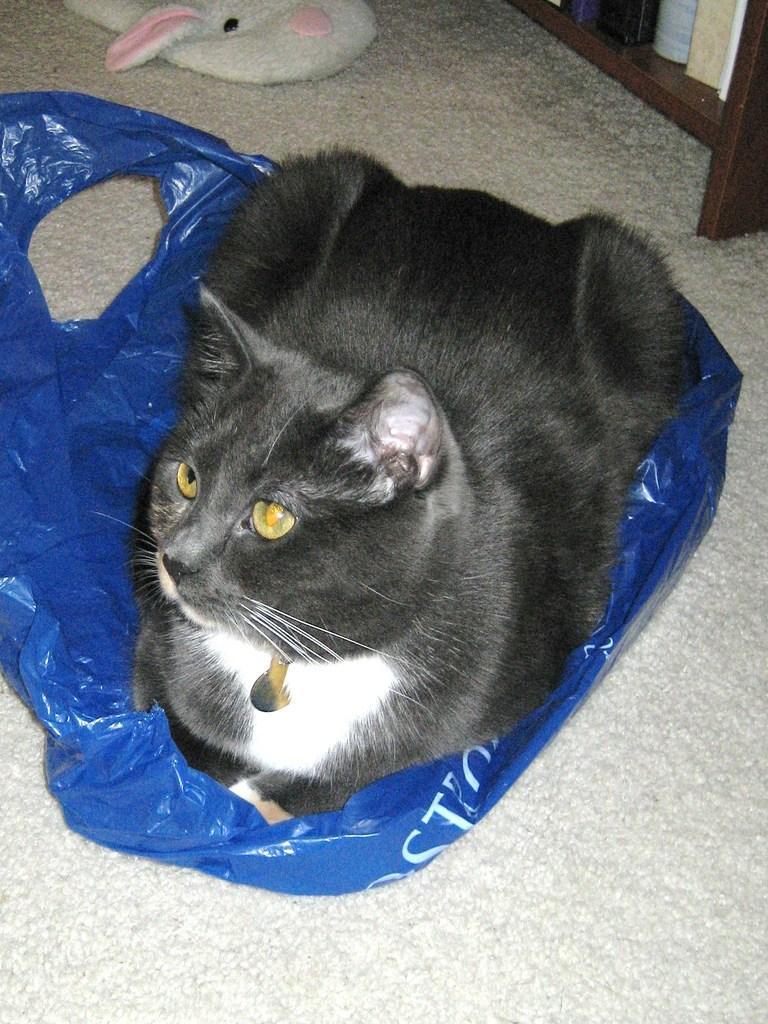Describe this image in one or two sentences. Here we can see a black sitting on a blue cover on the floor. At the top we can see a toy on the floor and books on a rack. 